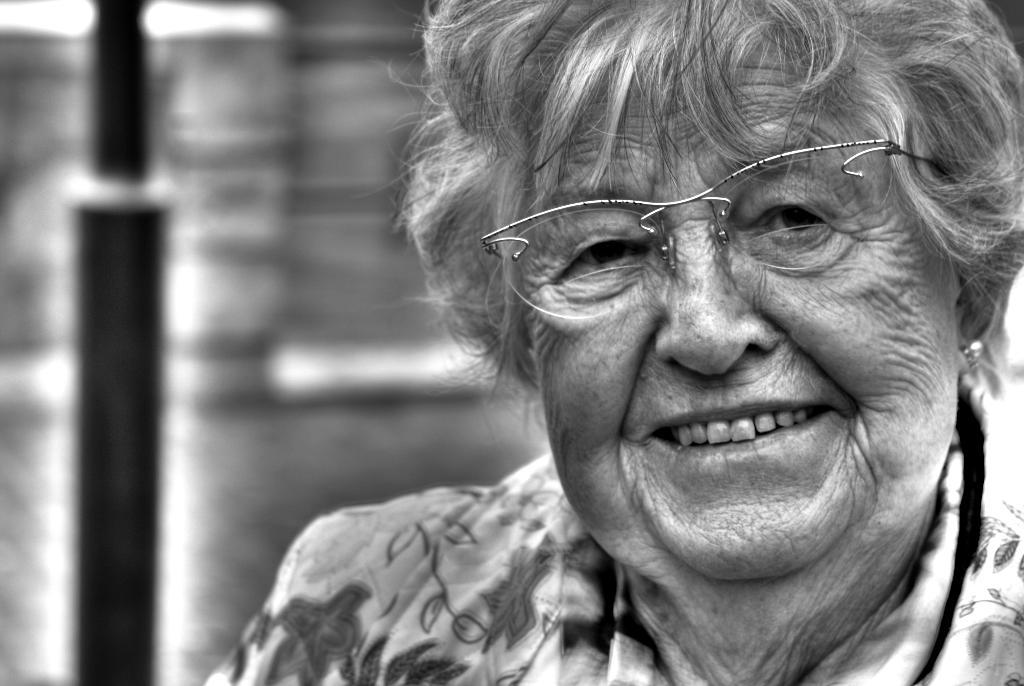What is the main subject of the image? There is a person in the image. What is the person wearing? The person is wearing a dress and specs. Can you describe the background of the image? The background of the image is blurred. What type of receipt can be seen in the person's hand in the image? There is no receipt visible in the person's hand or anywhere else in the image. 